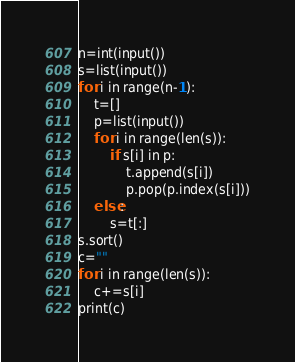<code> <loc_0><loc_0><loc_500><loc_500><_Python_>n=int(input())
s=list(input())
for i in range(n-1):
    t=[]
    p=list(input())
    for i in range(len(s)):
        if s[i] in p:
            t.append(s[i])
            p.pop(p.index(s[i]))
    else:
        s=t[:]
s.sort()
c=""
for i in range(len(s)):
    c+=s[i]
print(c)</code> 